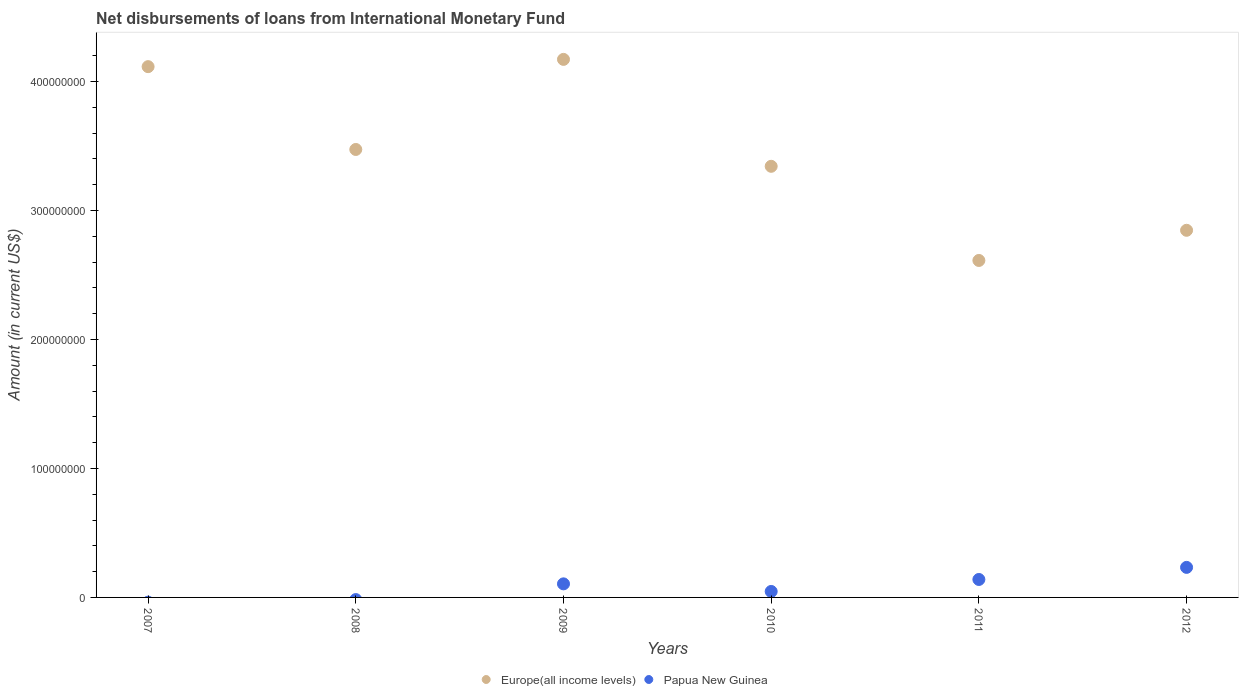How many different coloured dotlines are there?
Your answer should be compact. 2. What is the amount of loans disbursed in Europe(all income levels) in 2012?
Give a very brief answer. 2.85e+08. Across all years, what is the maximum amount of loans disbursed in Europe(all income levels)?
Give a very brief answer. 4.17e+08. What is the total amount of loans disbursed in Papua New Guinea in the graph?
Your response must be concise. 5.24e+07. What is the difference between the amount of loans disbursed in Papua New Guinea in 2009 and that in 2011?
Keep it short and to the point. -3.40e+06. What is the difference between the amount of loans disbursed in Europe(all income levels) in 2009 and the amount of loans disbursed in Papua New Guinea in 2012?
Offer a terse response. 3.94e+08. What is the average amount of loans disbursed in Europe(all income levels) per year?
Keep it short and to the point. 3.43e+08. In the year 2011, what is the difference between the amount of loans disbursed in Europe(all income levels) and amount of loans disbursed in Papua New Guinea?
Keep it short and to the point. 2.47e+08. What is the ratio of the amount of loans disbursed in Europe(all income levels) in 2011 to that in 2012?
Your response must be concise. 0.92. Is the difference between the amount of loans disbursed in Europe(all income levels) in 2011 and 2012 greater than the difference between the amount of loans disbursed in Papua New Guinea in 2011 and 2012?
Your answer should be very brief. No. What is the difference between the highest and the second highest amount of loans disbursed in Papua New Guinea?
Your answer should be very brief. 9.38e+06. What is the difference between the highest and the lowest amount of loans disbursed in Papua New Guinea?
Ensure brevity in your answer.  2.33e+07. Is the sum of the amount of loans disbursed in Europe(all income levels) in 2007 and 2008 greater than the maximum amount of loans disbursed in Papua New Guinea across all years?
Your answer should be compact. Yes. Does the amount of loans disbursed in Europe(all income levels) monotonically increase over the years?
Provide a succinct answer. No. Is the amount of loans disbursed in Europe(all income levels) strictly greater than the amount of loans disbursed in Papua New Guinea over the years?
Offer a terse response. Yes. How many dotlines are there?
Your response must be concise. 2. Where does the legend appear in the graph?
Your answer should be very brief. Bottom center. How many legend labels are there?
Your answer should be very brief. 2. How are the legend labels stacked?
Give a very brief answer. Horizontal. What is the title of the graph?
Provide a succinct answer. Net disbursements of loans from International Monetary Fund. What is the label or title of the X-axis?
Keep it short and to the point. Years. What is the Amount (in current US$) in Europe(all income levels) in 2007?
Provide a short and direct response. 4.12e+08. What is the Amount (in current US$) of Papua New Guinea in 2007?
Make the answer very short. 0. What is the Amount (in current US$) in Europe(all income levels) in 2008?
Provide a succinct answer. 3.47e+08. What is the Amount (in current US$) of Papua New Guinea in 2008?
Your response must be concise. 0. What is the Amount (in current US$) in Europe(all income levels) in 2009?
Your answer should be very brief. 4.17e+08. What is the Amount (in current US$) in Papua New Guinea in 2009?
Give a very brief answer. 1.05e+07. What is the Amount (in current US$) in Europe(all income levels) in 2010?
Provide a succinct answer. 3.34e+08. What is the Amount (in current US$) of Papua New Guinea in 2010?
Offer a terse response. 4.62e+06. What is the Amount (in current US$) of Europe(all income levels) in 2011?
Give a very brief answer. 2.61e+08. What is the Amount (in current US$) of Papua New Guinea in 2011?
Your answer should be compact. 1.39e+07. What is the Amount (in current US$) of Europe(all income levels) in 2012?
Give a very brief answer. 2.85e+08. What is the Amount (in current US$) in Papua New Guinea in 2012?
Ensure brevity in your answer.  2.33e+07. Across all years, what is the maximum Amount (in current US$) in Europe(all income levels)?
Your answer should be very brief. 4.17e+08. Across all years, what is the maximum Amount (in current US$) in Papua New Guinea?
Provide a succinct answer. 2.33e+07. Across all years, what is the minimum Amount (in current US$) in Europe(all income levels)?
Make the answer very short. 2.61e+08. Across all years, what is the minimum Amount (in current US$) in Papua New Guinea?
Offer a terse response. 0. What is the total Amount (in current US$) in Europe(all income levels) in the graph?
Provide a short and direct response. 2.06e+09. What is the total Amount (in current US$) in Papua New Guinea in the graph?
Make the answer very short. 5.24e+07. What is the difference between the Amount (in current US$) in Europe(all income levels) in 2007 and that in 2008?
Your answer should be compact. 6.42e+07. What is the difference between the Amount (in current US$) in Europe(all income levels) in 2007 and that in 2009?
Ensure brevity in your answer.  -5.63e+06. What is the difference between the Amount (in current US$) of Europe(all income levels) in 2007 and that in 2010?
Offer a terse response. 7.73e+07. What is the difference between the Amount (in current US$) in Europe(all income levels) in 2007 and that in 2011?
Offer a very short reply. 1.50e+08. What is the difference between the Amount (in current US$) in Europe(all income levels) in 2007 and that in 2012?
Provide a short and direct response. 1.27e+08. What is the difference between the Amount (in current US$) of Europe(all income levels) in 2008 and that in 2009?
Provide a short and direct response. -6.98e+07. What is the difference between the Amount (in current US$) in Europe(all income levels) in 2008 and that in 2010?
Make the answer very short. 1.31e+07. What is the difference between the Amount (in current US$) of Europe(all income levels) in 2008 and that in 2011?
Offer a very short reply. 8.61e+07. What is the difference between the Amount (in current US$) in Europe(all income levels) in 2008 and that in 2012?
Ensure brevity in your answer.  6.27e+07. What is the difference between the Amount (in current US$) in Europe(all income levels) in 2009 and that in 2010?
Provide a succinct answer. 8.29e+07. What is the difference between the Amount (in current US$) in Papua New Guinea in 2009 and that in 2010?
Offer a terse response. 5.90e+06. What is the difference between the Amount (in current US$) in Europe(all income levels) in 2009 and that in 2011?
Your answer should be very brief. 1.56e+08. What is the difference between the Amount (in current US$) in Papua New Guinea in 2009 and that in 2011?
Ensure brevity in your answer.  -3.40e+06. What is the difference between the Amount (in current US$) of Europe(all income levels) in 2009 and that in 2012?
Provide a short and direct response. 1.33e+08. What is the difference between the Amount (in current US$) of Papua New Guinea in 2009 and that in 2012?
Provide a succinct answer. -1.28e+07. What is the difference between the Amount (in current US$) of Europe(all income levels) in 2010 and that in 2011?
Ensure brevity in your answer.  7.30e+07. What is the difference between the Amount (in current US$) of Papua New Guinea in 2010 and that in 2011?
Offer a terse response. -9.30e+06. What is the difference between the Amount (in current US$) of Europe(all income levels) in 2010 and that in 2012?
Keep it short and to the point. 4.96e+07. What is the difference between the Amount (in current US$) in Papua New Guinea in 2010 and that in 2012?
Provide a short and direct response. -1.87e+07. What is the difference between the Amount (in current US$) in Europe(all income levels) in 2011 and that in 2012?
Your answer should be very brief. -2.34e+07. What is the difference between the Amount (in current US$) in Papua New Guinea in 2011 and that in 2012?
Your response must be concise. -9.38e+06. What is the difference between the Amount (in current US$) in Europe(all income levels) in 2007 and the Amount (in current US$) in Papua New Guinea in 2009?
Keep it short and to the point. 4.01e+08. What is the difference between the Amount (in current US$) of Europe(all income levels) in 2007 and the Amount (in current US$) of Papua New Guinea in 2010?
Ensure brevity in your answer.  4.07e+08. What is the difference between the Amount (in current US$) in Europe(all income levels) in 2007 and the Amount (in current US$) in Papua New Guinea in 2011?
Your answer should be very brief. 3.98e+08. What is the difference between the Amount (in current US$) of Europe(all income levels) in 2007 and the Amount (in current US$) of Papua New Guinea in 2012?
Give a very brief answer. 3.88e+08. What is the difference between the Amount (in current US$) of Europe(all income levels) in 2008 and the Amount (in current US$) of Papua New Guinea in 2009?
Your answer should be compact. 3.37e+08. What is the difference between the Amount (in current US$) of Europe(all income levels) in 2008 and the Amount (in current US$) of Papua New Guinea in 2010?
Make the answer very short. 3.43e+08. What is the difference between the Amount (in current US$) of Europe(all income levels) in 2008 and the Amount (in current US$) of Papua New Guinea in 2011?
Your answer should be compact. 3.33e+08. What is the difference between the Amount (in current US$) of Europe(all income levels) in 2008 and the Amount (in current US$) of Papua New Guinea in 2012?
Give a very brief answer. 3.24e+08. What is the difference between the Amount (in current US$) of Europe(all income levels) in 2009 and the Amount (in current US$) of Papua New Guinea in 2010?
Your answer should be compact. 4.13e+08. What is the difference between the Amount (in current US$) in Europe(all income levels) in 2009 and the Amount (in current US$) in Papua New Guinea in 2011?
Your response must be concise. 4.03e+08. What is the difference between the Amount (in current US$) of Europe(all income levels) in 2009 and the Amount (in current US$) of Papua New Guinea in 2012?
Provide a short and direct response. 3.94e+08. What is the difference between the Amount (in current US$) of Europe(all income levels) in 2010 and the Amount (in current US$) of Papua New Guinea in 2011?
Offer a very short reply. 3.20e+08. What is the difference between the Amount (in current US$) of Europe(all income levels) in 2010 and the Amount (in current US$) of Papua New Guinea in 2012?
Provide a succinct answer. 3.11e+08. What is the difference between the Amount (in current US$) in Europe(all income levels) in 2011 and the Amount (in current US$) in Papua New Guinea in 2012?
Provide a succinct answer. 2.38e+08. What is the average Amount (in current US$) in Europe(all income levels) per year?
Your answer should be compact. 3.43e+08. What is the average Amount (in current US$) of Papua New Guinea per year?
Ensure brevity in your answer.  8.73e+06. In the year 2009, what is the difference between the Amount (in current US$) in Europe(all income levels) and Amount (in current US$) in Papua New Guinea?
Your answer should be compact. 4.07e+08. In the year 2010, what is the difference between the Amount (in current US$) of Europe(all income levels) and Amount (in current US$) of Papua New Guinea?
Ensure brevity in your answer.  3.30e+08. In the year 2011, what is the difference between the Amount (in current US$) in Europe(all income levels) and Amount (in current US$) in Papua New Guinea?
Make the answer very short. 2.47e+08. In the year 2012, what is the difference between the Amount (in current US$) in Europe(all income levels) and Amount (in current US$) in Papua New Guinea?
Offer a very short reply. 2.61e+08. What is the ratio of the Amount (in current US$) of Europe(all income levels) in 2007 to that in 2008?
Your answer should be compact. 1.18. What is the ratio of the Amount (in current US$) of Europe(all income levels) in 2007 to that in 2009?
Offer a terse response. 0.99. What is the ratio of the Amount (in current US$) in Europe(all income levels) in 2007 to that in 2010?
Keep it short and to the point. 1.23. What is the ratio of the Amount (in current US$) in Europe(all income levels) in 2007 to that in 2011?
Give a very brief answer. 1.58. What is the ratio of the Amount (in current US$) of Europe(all income levels) in 2007 to that in 2012?
Your response must be concise. 1.45. What is the ratio of the Amount (in current US$) in Europe(all income levels) in 2008 to that in 2009?
Your answer should be very brief. 0.83. What is the ratio of the Amount (in current US$) in Europe(all income levels) in 2008 to that in 2010?
Your answer should be very brief. 1.04. What is the ratio of the Amount (in current US$) of Europe(all income levels) in 2008 to that in 2011?
Ensure brevity in your answer.  1.33. What is the ratio of the Amount (in current US$) of Europe(all income levels) in 2008 to that in 2012?
Your answer should be compact. 1.22. What is the ratio of the Amount (in current US$) of Europe(all income levels) in 2009 to that in 2010?
Your response must be concise. 1.25. What is the ratio of the Amount (in current US$) of Papua New Guinea in 2009 to that in 2010?
Your response must be concise. 2.28. What is the ratio of the Amount (in current US$) of Europe(all income levels) in 2009 to that in 2011?
Offer a terse response. 1.6. What is the ratio of the Amount (in current US$) in Papua New Guinea in 2009 to that in 2011?
Give a very brief answer. 0.76. What is the ratio of the Amount (in current US$) of Europe(all income levels) in 2009 to that in 2012?
Give a very brief answer. 1.47. What is the ratio of the Amount (in current US$) of Papua New Guinea in 2009 to that in 2012?
Ensure brevity in your answer.  0.45. What is the ratio of the Amount (in current US$) of Europe(all income levels) in 2010 to that in 2011?
Keep it short and to the point. 1.28. What is the ratio of the Amount (in current US$) in Papua New Guinea in 2010 to that in 2011?
Offer a very short reply. 0.33. What is the ratio of the Amount (in current US$) of Europe(all income levels) in 2010 to that in 2012?
Offer a very short reply. 1.17. What is the ratio of the Amount (in current US$) in Papua New Guinea in 2010 to that in 2012?
Provide a short and direct response. 0.2. What is the ratio of the Amount (in current US$) of Europe(all income levels) in 2011 to that in 2012?
Your response must be concise. 0.92. What is the ratio of the Amount (in current US$) in Papua New Guinea in 2011 to that in 2012?
Your answer should be very brief. 0.6. What is the difference between the highest and the second highest Amount (in current US$) of Europe(all income levels)?
Ensure brevity in your answer.  5.63e+06. What is the difference between the highest and the second highest Amount (in current US$) of Papua New Guinea?
Provide a short and direct response. 9.38e+06. What is the difference between the highest and the lowest Amount (in current US$) of Europe(all income levels)?
Make the answer very short. 1.56e+08. What is the difference between the highest and the lowest Amount (in current US$) of Papua New Guinea?
Keep it short and to the point. 2.33e+07. 